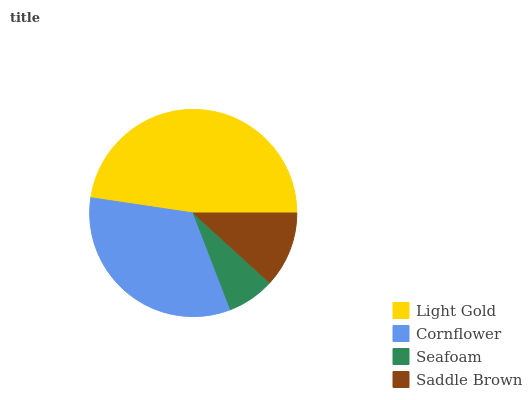Is Seafoam the minimum?
Answer yes or no. Yes. Is Light Gold the maximum?
Answer yes or no. Yes. Is Cornflower the minimum?
Answer yes or no. No. Is Cornflower the maximum?
Answer yes or no. No. Is Light Gold greater than Cornflower?
Answer yes or no. Yes. Is Cornflower less than Light Gold?
Answer yes or no. Yes. Is Cornflower greater than Light Gold?
Answer yes or no. No. Is Light Gold less than Cornflower?
Answer yes or no. No. Is Cornflower the high median?
Answer yes or no. Yes. Is Saddle Brown the low median?
Answer yes or no. Yes. Is Seafoam the high median?
Answer yes or no. No. Is Seafoam the low median?
Answer yes or no. No. 